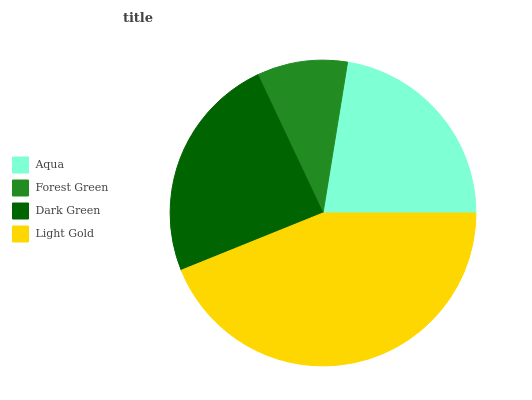Is Forest Green the minimum?
Answer yes or no. Yes. Is Light Gold the maximum?
Answer yes or no. Yes. Is Dark Green the minimum?
Answer yes or no. No. Is Dark Green the maximum?
Answer yes or no. No. Is Dark Green greater than Forest Green?
Answer yes or no. Yes. Is Forest Green less than Dark Green?
Answer yes or no. Yes. Is Forest Green greater than Dark Green?
Answer yes or no. No. Is Dark Green less than Forest Green?
Answer yes or no. No. Is Dark Green the high median?
Answer yes or no. Yes. Is Aqua the low median?
Answer yes or no. Yes. Is Light Gold the high median?
Answer yes or no. No. Is Light Gold the low median?
Answer yes or no. No. 